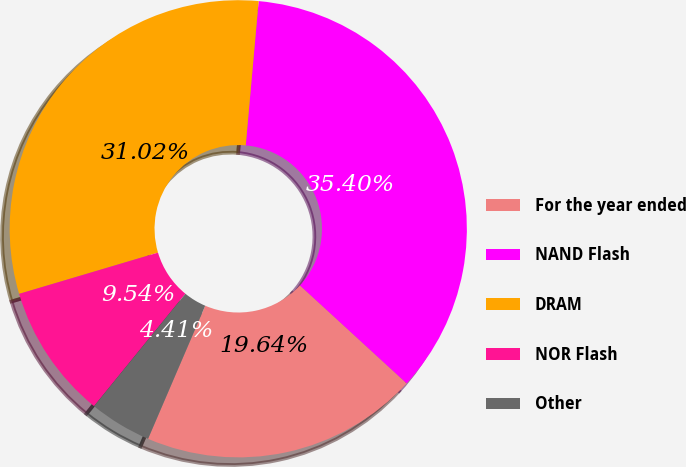Convert chart to OTSL. <chart><loc_0><loc_0><loc_500><loc_500><pie_chart><fcel>For the year ended<fcel>NAND Flash<fcel>DRAM<fcel>NOR Flash<fcel>Other<nl><fcel>19.64%<fcel>35.4%<fcel>31.02%<fcel>9.54%<fcel>4.41%<nl></chart> 